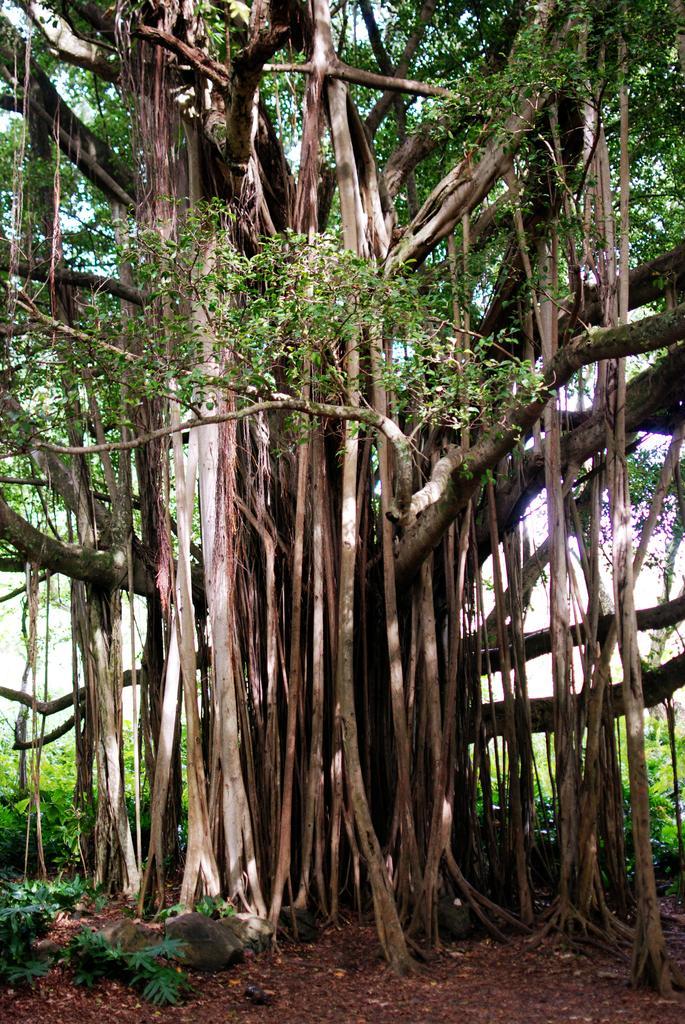Could you give a brief overview of what you see in this image? In this image we can see a banyan tree. We can also see the plants, stones and also the dried leaves at the bottom. 